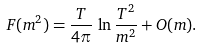<formula> <loc_0><loc_0><loc_500><loc_500>F ( m ^ { 2 } ) = \frac { T } { 4 \pi } \, \ln \frac { T ^ { 2 } } { m ^ { 2 } } + O ( m ) .</formula> 